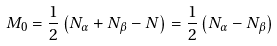Convert formula to latex. <formula><loc_0><loc_0><loc_500><loc_500>M _ { 0 } = \frac { 1 } { 2 } \left ( N _ { \alpha } + N _ { \beta } - N \right ) = \frac { 1 } { 2 } \left ( N _ { \alpha } - N _ { \beta } \right )</formula> 